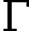<formula> <loc_0><loc_0><loc_500><loc_500>\Gamma</formula> 